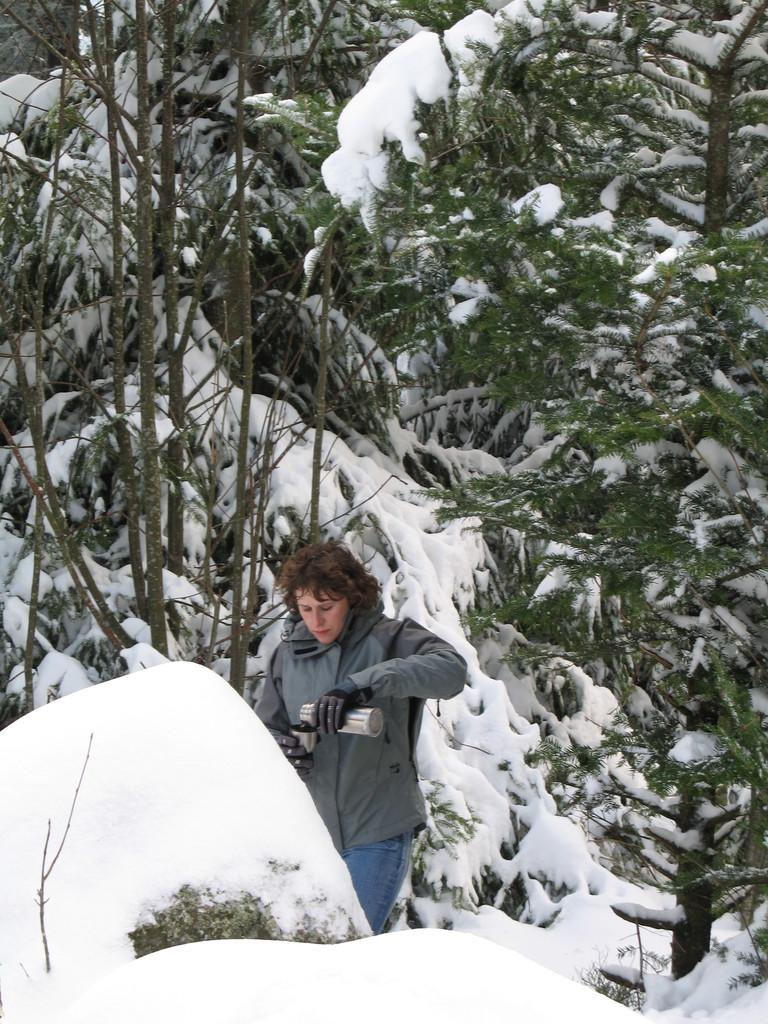Who is the main subject in the image? There is a woman in the image. What is the woman holding in her hand? The woman is holding a steel bottle in her hand. What type of clothing is the woman wearing? The woman is wearing a coat and trousers. What is the condition of the trees in the image? There is snow on the trees and there are also green trees in the image. How does the woman measure the temperature of the snow in the image? There is no thermometer or any indication of temperature measurement in the image. 